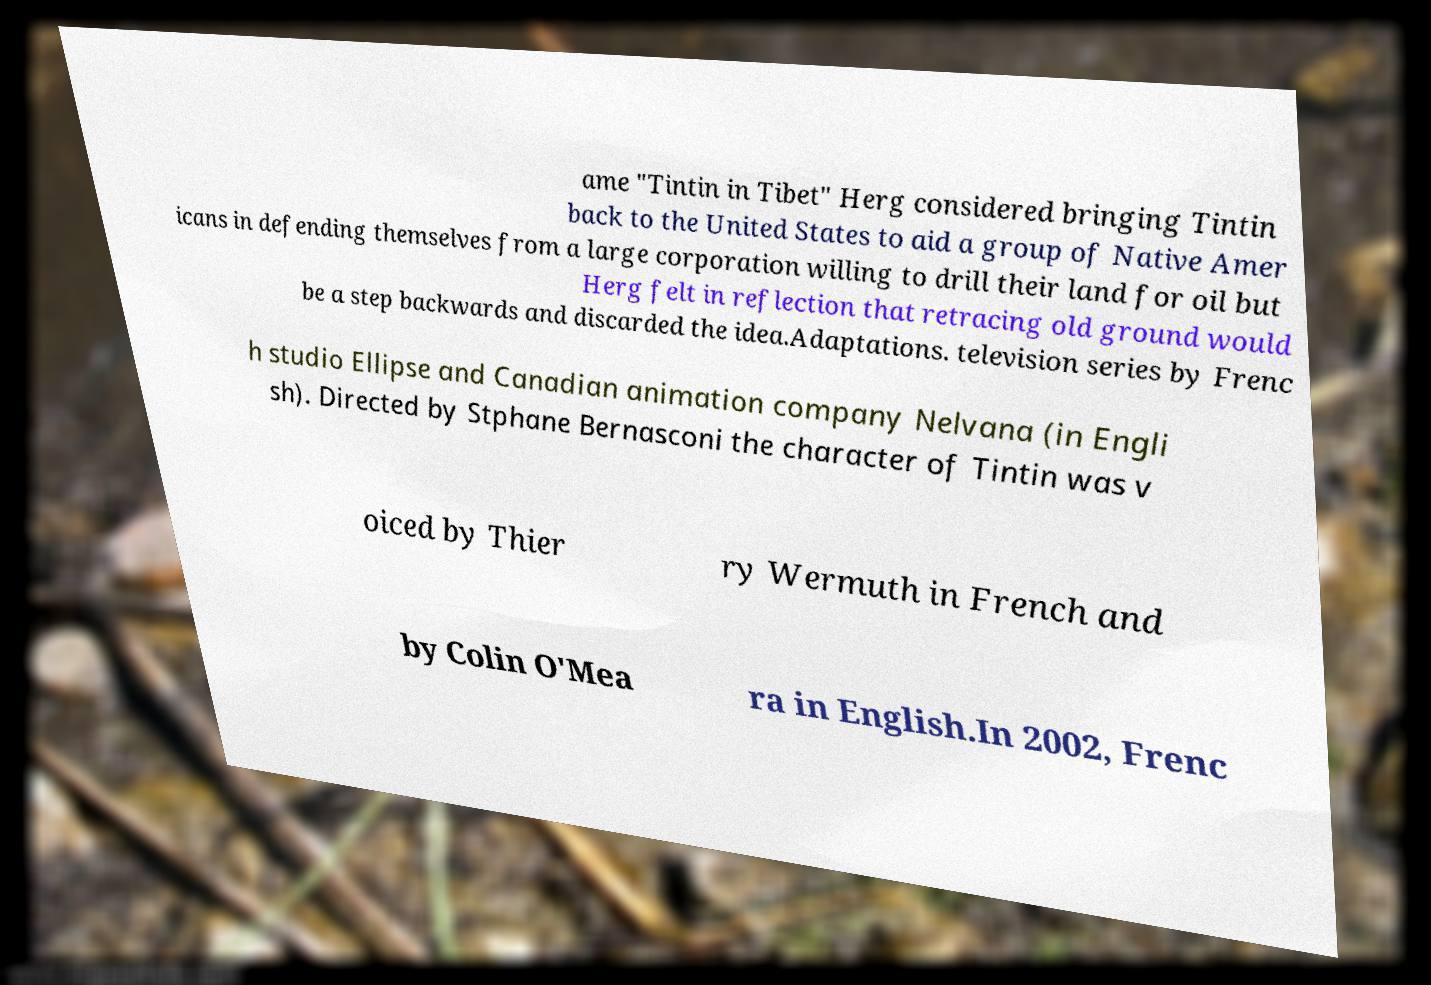Please identify and transcribe the text found in this image. ame "Tintin in Tibet" Herg considered bringing Tintin back to the United States to aid a group of Native Amer icans in defending themselves from a large corporation willing to drill their land for oil but Herg felt in reflection that retracing old ground would be a step backwards and discarded the idea.Adaptations. television series by Frenc h studio Ellipse and Canadian animation company Nelvana (in Engli sh). Directed by Stphane Bernasconi the character of Tintin was v oiced by Thier ry Wermuth in French and by Colin O'Mea ra in English.In 2002, Frenc 